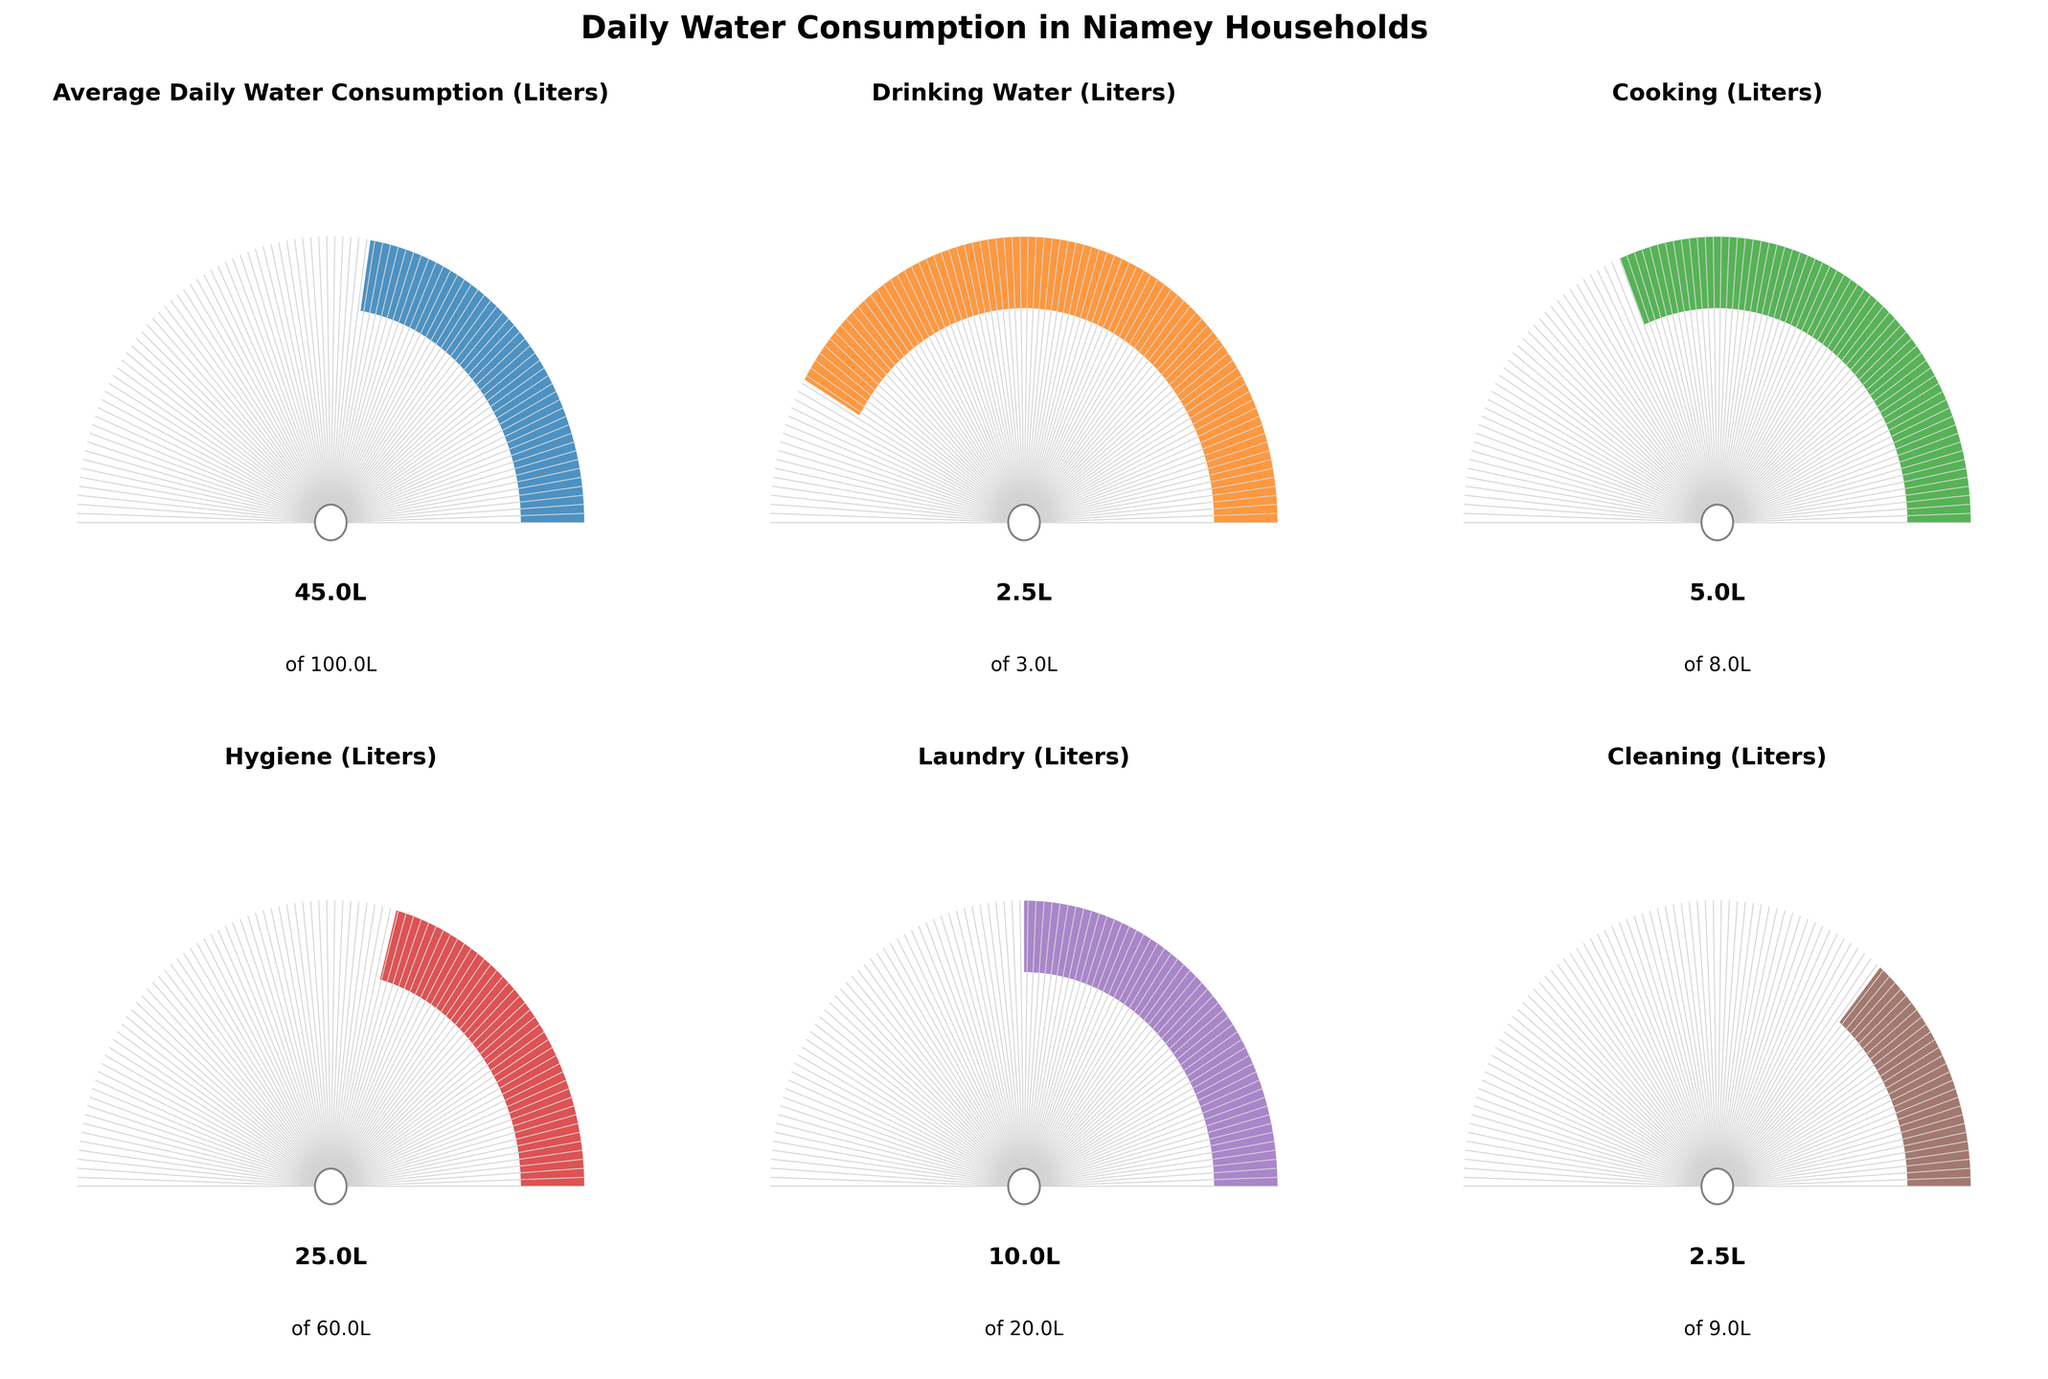What's the title of the figure? The title of the figure is written at the top of the chart in bold.
Answer: Daily Water Consumption in Niamey Households What are the actual and recommended daily water consumption levels for cooking? The chart for Cooking shows that the actual daily water consumption is labeled as 5.0L, and the recommended level is 8.0L.
Answer: 5.0L and 8.0L How many categories of water consumption are displayed in the figure? There are six different gauge charts visible, each representing a different category of water consumption.
Answer: 6 Which category has the largest discrepancy between actual and recommended water consumption? By observing the gauges, the largest discrepancy between actual (25L) and recommended (60L) water consumption is visible in the Hygiene category.
Answer: Hygiene What percentage of the recommended levels is the actual daily water consumption for Cleaning? The gauge for Cleaning shows the wedge filling up to about 27.78% of the area (2.5L out of 9L). This percentage is approximately calculated as (2.5 / 9) * 100.
Answer: Approximately 27.78% Compare the actual vs. recommended water consumption for Laundry. Is the actual consumption more or less than half the recommended value? The actual consumption for Laundry is 10L, and the recommended is 20L. Since 10 is exactly half of 20, the actual consumption is exactly half of the recommended value.
Answer: Exactly half What's the total recommended daily water consumption for all shown categories? Summing the recommended values for all categories: 100 + 3 + 8 + 60 + 20 + 9 = 200L.
Answer: 200L Is the actual average daily water consumption in Niamey households greater or lesser than half of the recommended average? The actual average daily water consumption is 45L, and the recommended average is 100L. Since 45 is less than half of 100, it is lesser.
Answer: Lesser Among the given categories, which ones have actual daily water consumption greater than half of the recommended levels? Cooking (5L out of 8L), Laundry (10L out of 20L), and Drinking Water (2.5L out of 3L) all have actual values greater than half their recommended levels.
Answer: Cooking, Laundry, Drinking Water What are the actual daily water consumption values for Drinking Water and Cleaning? Is the consumption rate the same for these two categories? The gauge charts for Drinking Water and Cleaning both show an actual consumption of 2.5L, meaning the consumption rate is the same for these two categories.
Answer: Yes, both are 2.5L 